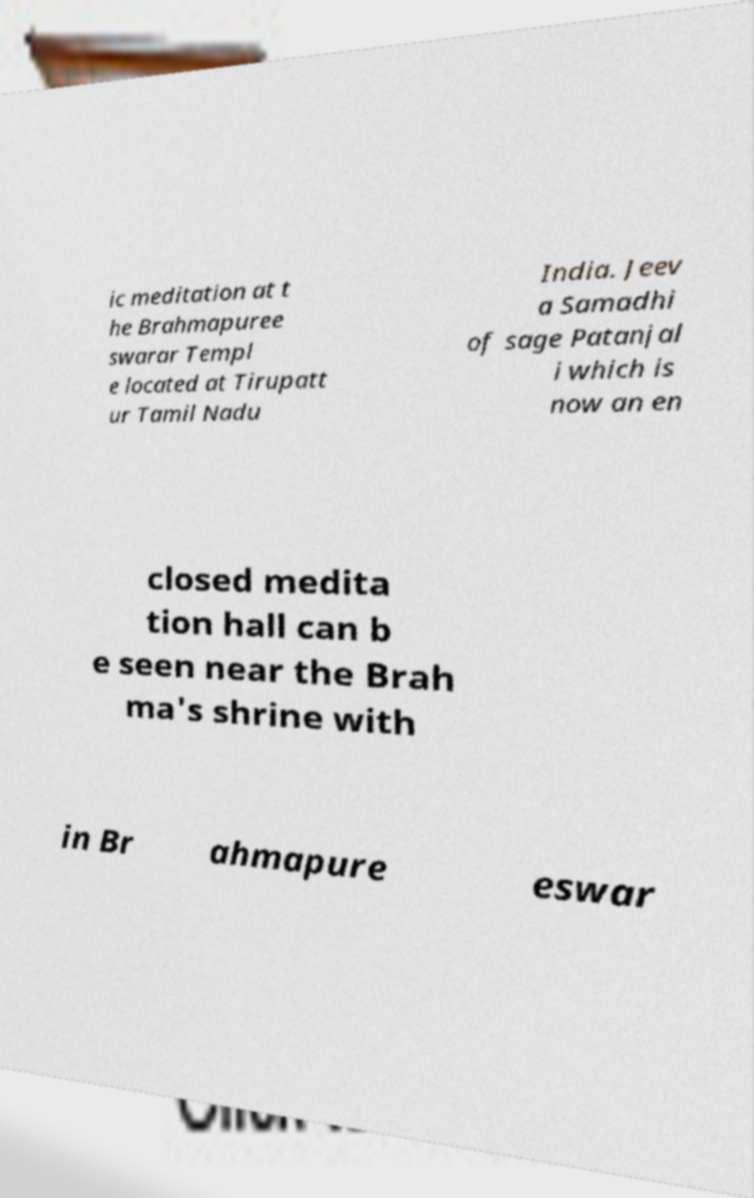I need the written content from this picture converted into text. Can you do that? ic meditation at t he Brahmapuree swarar Templ e located at Tirupatt ur Tamil Nadu India. Jeev a Samadhi of sage Patanjal i which is now an en closed medita tion hall can b e seen near the Brah ma's shrine with in Br ahmapure eswar 